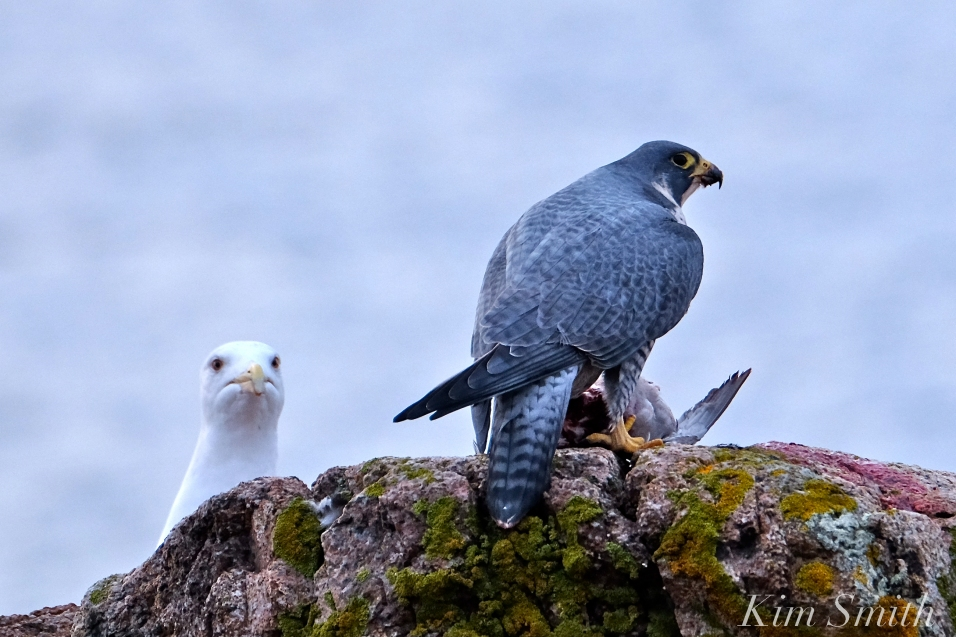What can we infer about the habitat of the Peregrine Falcon based on this image? The image indicates that the Peregrine Falcon is in a coastal or rocky cliff area, which aligns well with their known habitats. These birds are often found in open landscapes, including mountain ranges, river valleys, and coastlines, where they have a good vantage point for spotting prey. The rocky surface covered with some moss and lichen suggests a potentially moist and natural environment, possibly near the sea, where the presence of the gull reinforces the marine setting. Do the types of rocks and plants in the image provide any specific information about the location? Indeed, the rocks and plants visible in the image can provide clues to the location. The moss and lichen growth on the rocks suggest a damp environment, likely close to a body of water such as the sea. This hints at a coastal habitat, which is a common hunting ground for Peregrine Falcons. They prefer such areas because of the abundant prey and high perches that allow for effective hunting. The specific types of moss and lichen can sometimes help in identifying the region, although further detail or expert analysis would be required for precise identification. 